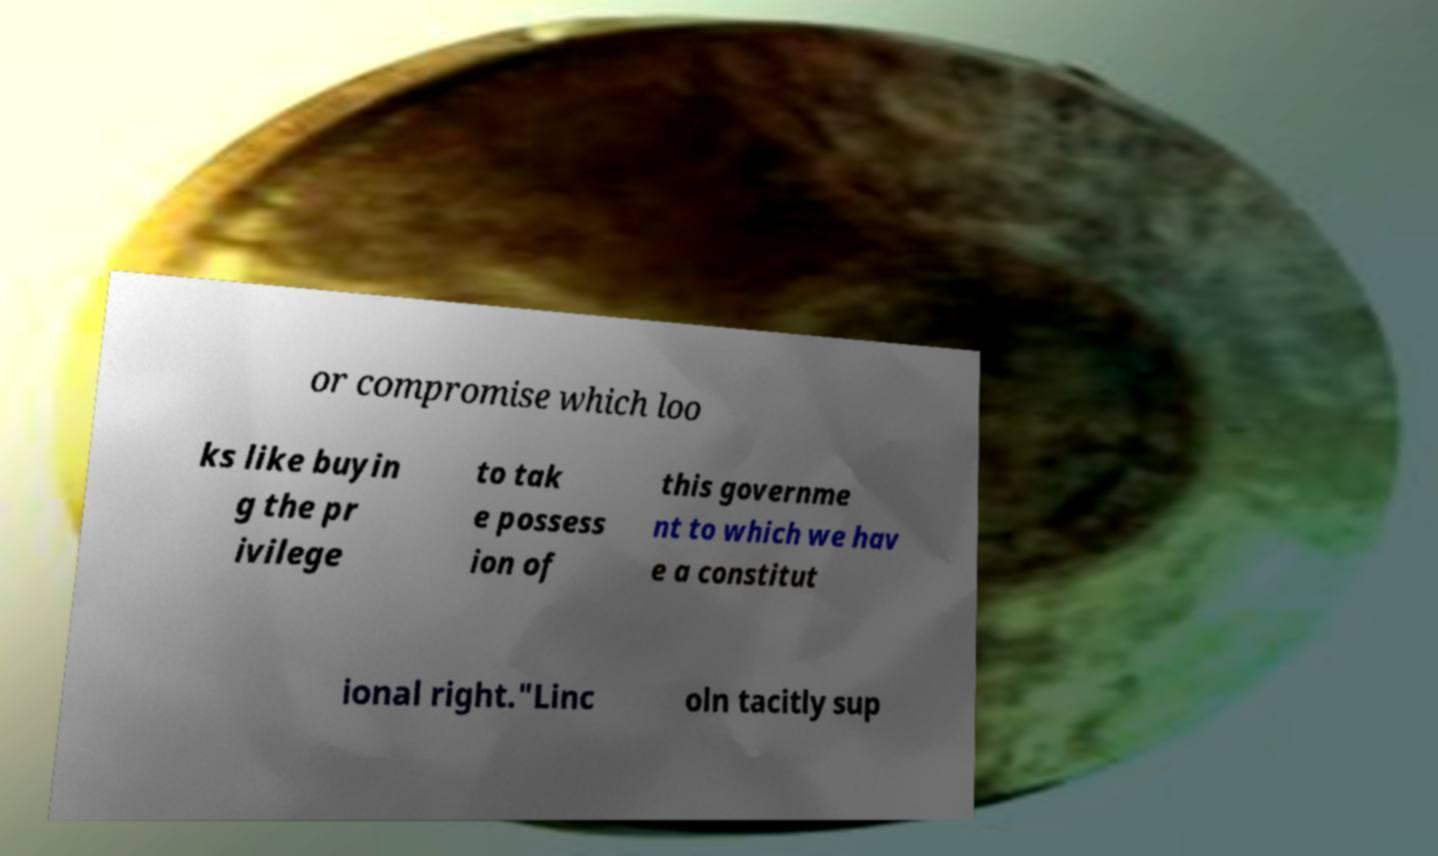I need the written content from this picture converted into text. Can you do that? or compromise which loo ks like buyin g the pr ivilege to tak e possess ion of this governme nt to which we hav e a constitut ional right."Linc oln tacitly sup 